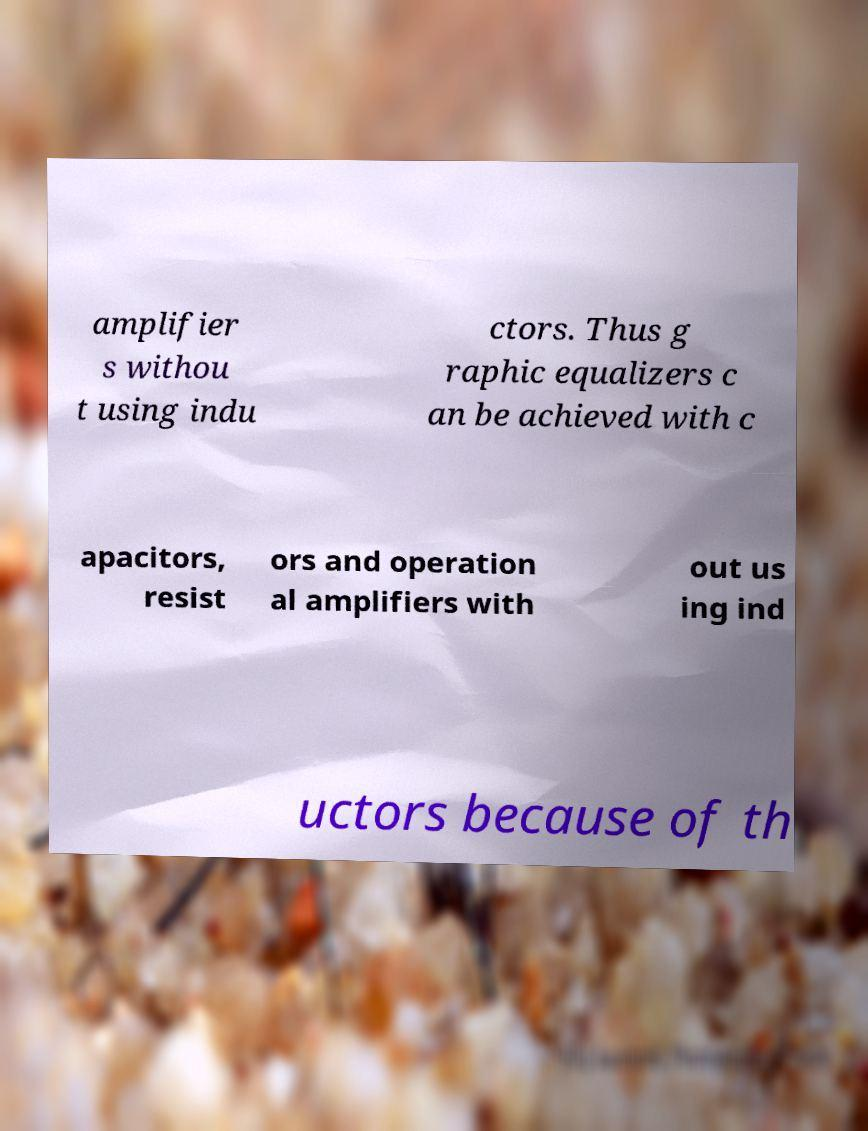Could you assist in decoding the text presented in this image and type it out clearly? amplifier s withou t using indu ctors. Thus g raphic equalizers c an be achieved with c apacitors, resist ors and operation al amplifiers with out us ing ind uctors because of th 